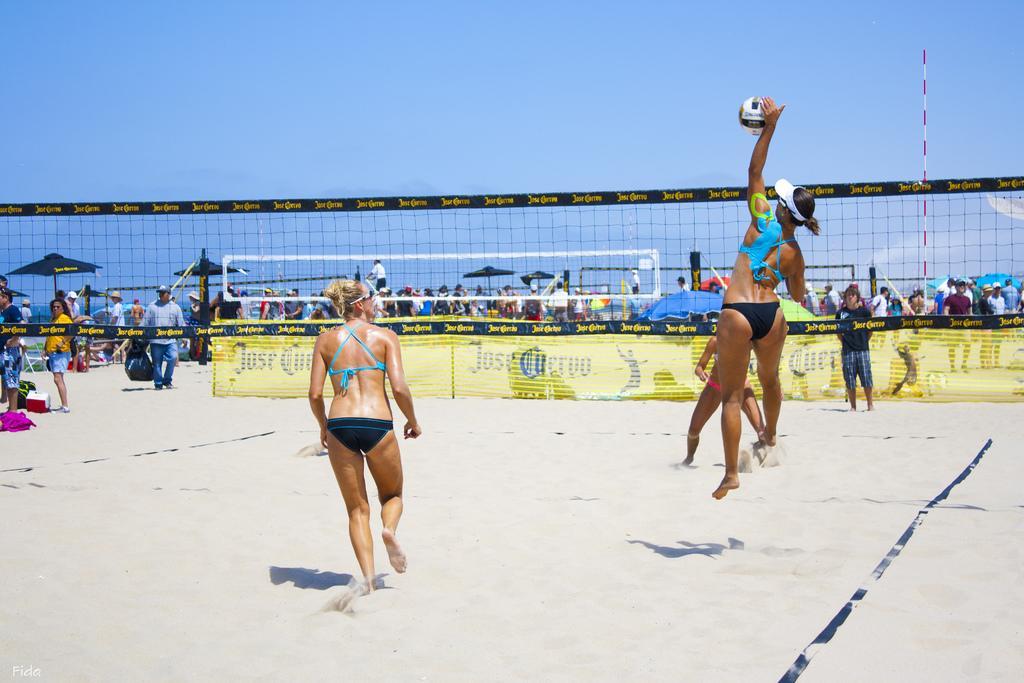Can you describe this image briefly? In the center of the image there are people playing volleyball. In the background of the image there are many people. There is a pole. 